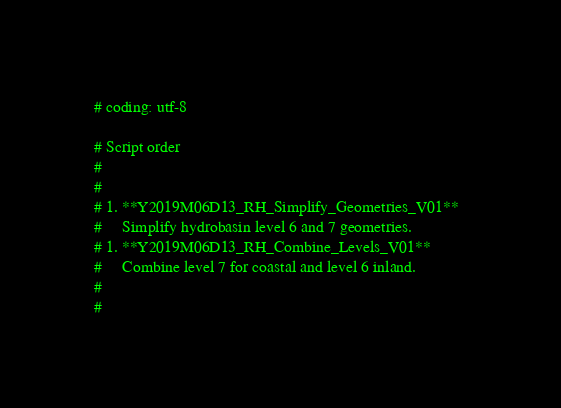<code> <loc_0><loc_0><loc_500><loc_500><_Python_>
# coding: utf-8

# Script order
# 
# 
# 1. **Y2019M06D13_RH_Simplify_Geometries_V01**  
#     Simplify hydrobasin level 6 and 7 geometries. 
# 1. **Y2019M06D13_RH_Combine_Levels_V01**  
#     Combine level 7 for coastal and level 6 inland.
# 
# 
</code> 